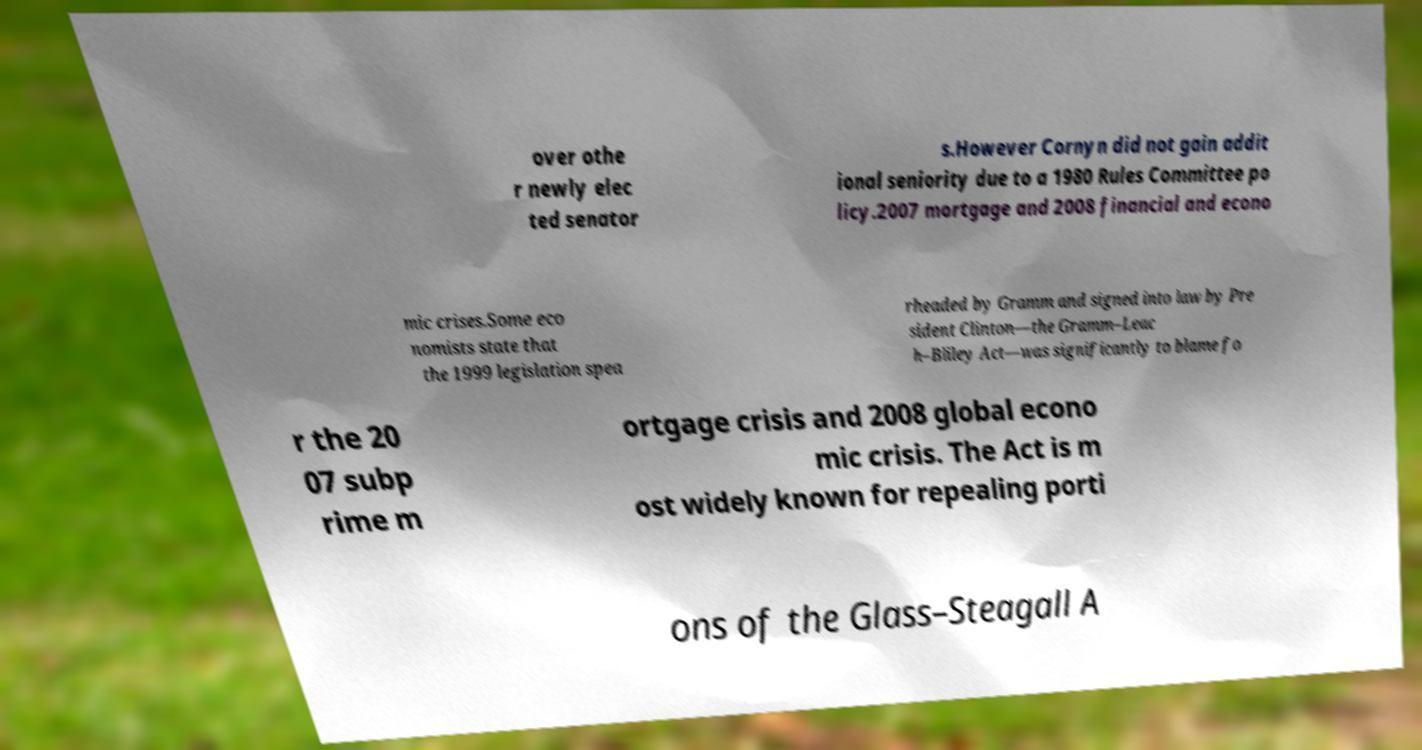There's text embedded in this image that I need extracted. Can you transcribe it verbatim? over othe r newly elec ted senator s.However Cornyn did not gain addit ional seniority due to a 1980 Rules Committee po licy.2007 mortgage and 2008 financial and econo mic crises.Some eco nomists state that the 1999 legislation spea rheaded by Gramm and signed into law by Pre sident Clinton—the Gramm–Leac h–Bliley Act—was significantly to blame fo r the 20 07 subp rime m ortgage crisis and 2008 global econo mic crisis. The Act is m ost widely known for repealing porti ons of the Glass–Steagall A 